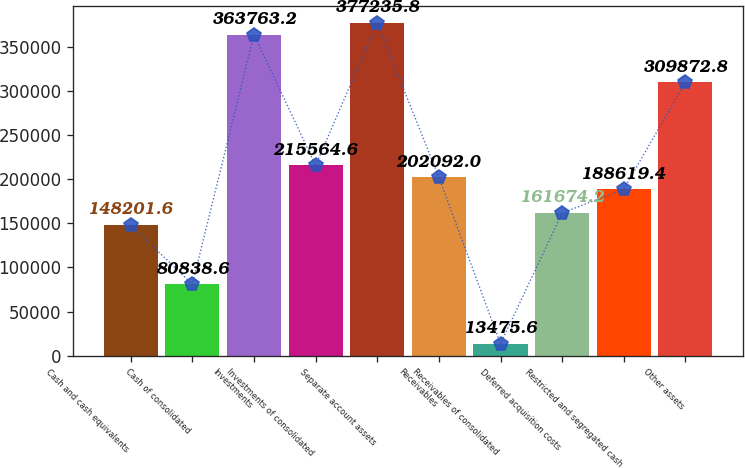Convert chart to OTSL. <chart><loc_0><loc_0><loc_500><loc_500><bar_chart><fcel>Cash and cash equivalents<fcel>Cash of consolidated<fcel>Investments<fcel>Investments of consolidated<fcel>Separate account assets<fcel>Receivables<fcel>Receivables of consolidated<fcel>Deferred acquisition costs<fcel>Restricted and segregated cash<fcel>Other assets<nl><fcel>148202<fcel>80838.6<fcel>363763<fcel>215565<fcel>377236<fcel>202092<fcel>13475.6<fcel>161674<fcel>188619<fcel>309873<nl></chart> 